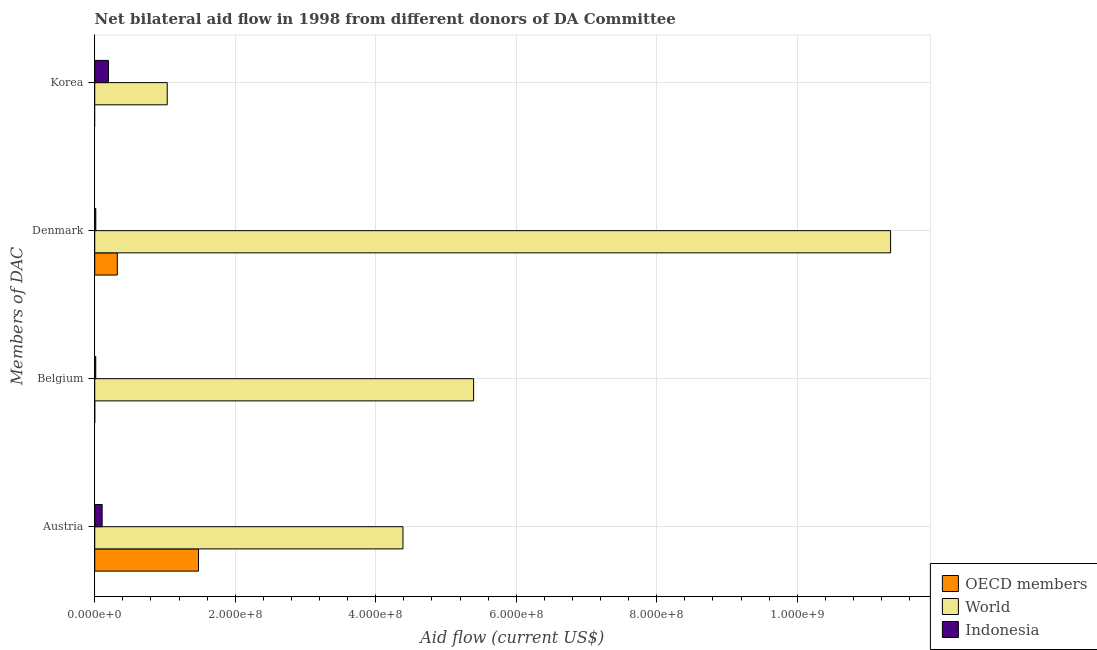How many groups of bars are there?
Give a very brief answer. 4. Are the number of bars per tick equal to the number of legend labels?
Your answer should be very brief. No. Are the number of bars on each tick of the Y-axis equal?
Offer a very short reply. No. How many bars are there on the 1st tick from the bottom?
Provide a succinct answer. 3. What is the label of the 1st group of bars from the top?
Provide a short and direct response. Korea. What is the amount of aid given by belgium in Indonesia?
Give a very brief answer. 1.45e+06. Across all countries, what is the maximum amount of aid given by belgium?
Provide a succinct answer. 5.39e+08. Across all countries, what is the minimum amount of aid given by denmark?
Keep it short and to the point. 1.51e+06. What is the total amount of aid given by belgium in the graph?
Offer a very short reply. 5.41e+08. What is the difference between the amount of aid given by austria in Indonesia and that in OECD members?
Ensure brevity in your answer.  -1.37e+08. What is the difference between the amount of aid given by belgium in World and the amount of aid given by denmark in Indonesia?
Provide a succinct answer. 5.38e+08. What is the average amount of aid given by belgium per country?
Keep it short and to the point. 1.80e+08. What is the difference between the amount of aid given by austria and amount of aid given by belgium in World?
Ensure brevity in your answer.  -1.01e+08. In how many countries, is the amount of aid given by austria greater than 920000000 US$?
Your response must be concise. 0. What is the ratio of the amount of aid given by denmark in OECD members to that in World?
Ensure brevity in your answer.  0.03. Is the amount of aid given by austria in OECD members less than that in World?
Provide a succinct answer. Yes. Is the difference between the amount of aid given by korea in World and Indonesia greater than the difference between the amount of aid given by austria in World and Indonesia?
Ensure brevity in your answer.  No. What is the difference between the highest and the second highest amount of aid given by austria?
Keep it short and to the point. 2.91e+08. What is the difference between the highest and the lowest amount of aid given by denmark?
Provide a succinct answer. 1.13e+09. Is the sum of the amount of aid given by belgium in World and Indonesia greater than the maximum amount of aid given by denmark across all countries?
Make the answer very short. No. How many bars are there?
Offer a very short reply. 10. Are all the bars in the graph horizontal?
Your answer should be very brief. Yes. How many countries are there in the graph?
Your answer should be very brief. 3. What is the difference between two consecutive major ticks on the X-axis?
Make the answer very short. 2.00e+08. Does the graph contain any zero values?
Offer a terse response. Yes. Does the graph contain grids?
Your answer should be compact. Yes. Where does the legend appear in the graph?
Ensure brevity in your answer.  Bottom right. How many legend labels are there?
Provide a short and direct response. 3. What is the title of the graph?
Keep it short and to the point. Net bilateral aid flow in 1998 from different donors of DA Committee. What is the label or title of the X-axis?
Offer a very short reply. Aid flow (current US$). What is the label or title of the Y-axis?
Ensure brevity in your answer.  Members of DAC. What is the Aid flow (current US$) of OECD members in Austria?
Offer a terse response. 1.48e+08. What is the Aid flow (current US$) in World in Austria?
Your answer should be very brief. 4.39e+08. What is the Aid flow (current US$) of Indonesia in Austria?
Offer a very short reply. 1.05e+07. What is the Aid flow (current US$) in OECD members in Belgium?
Your answer should be compact. 0. What is the Aid flow (current US$) in World in Belgium?
Provide a short and direct response. 5.39e+08. What is the Aid flow (current US$) in Indonesia in Belgium?
Your answer should be compact. 1.45e+06. What is the Aid flow (current US$) in OECD members in Denmark?
Your answer should be compact. 3.22e+07. What is the Aid flow (current US$) of World in Denmark?
Give a very brief answer. 1.13e+09. What is the Aid flow (current US$) in Indonesia in Denmark?
Your answer should be very brief. 1.51e+06. What is the Aid flow (current US$) in OECD members in Korea?
Your answer should be compact. 0. What is the Aid flow (current US$) of World in Korea?
Your answer should be very brief. 1.03e+08. What is the Aid flow (current US$) in Indonesia in Korea?
Provide a short and direct response. 1.96e+07. Across all Members of DAC, what is the maximum Aid flow (current US$) in OECD members?
Keep it short and to the point. 1.48e+08. Across all Members of DAC, what is the maximum Aid flow (current US$) in World?
Ensure brevity in your answer.  1.13e+09. Across all Members of DAC, what is the maximum Aid flow (current US$) in Indonesia?
Your answer should be compact. 1.96e+07. Across all Members of DAC, what is the minimum Aid flow (current US$) in World?
Keep it short and to the point. 1.03e+08. Across all Members of DAC, what is the minimum Aid flow (current US$) in Indonesia?
Offer a terse response. 1.45e+06. What is the total Aid flow (current US$) in OECD members in the graph?
Provide a short and direct response. 1.80e+08. What is the total Aid flow (current US$) in World in the graph?
Your answer should be very brief. 2.21e+09. What is the total Aid flow (current US$) of Indonesia in the graph?
Make the answer very short. 3.30e+07. What is the difference between the Aid flow (current US$) in World in Austria and that in Belgium?
Give a very brief answer. -1.01e+08. What is the difference between the Aid flow (current US$) in Indonesia in Austria and that in Belgium?
Your answer should be very brief. 9.09e+06. What is the difference between the Aid flow (current US$) of OECD members in Austria and that in Denmark?
Make the answer very short. 1.16e+08. What is the difference between the Aid flow (current US$) in World in Austria and that in Denmark?
Keep it short and to the point. -6.94e+08. What is the difference between the Aid flow (current US$) in Indonesia in Austria and that in Denmark?
Offer a very short reply. 9.03e+06. What is the difference between the Aid flow (current US$) of World in Austria and that in Korea?
Make the answer very short. 3.36e+08. What is the difference between the Aid flow (current US$) in Indonesia in Austria and that in Korea?
Offer a very short reply. -9.01e+06. What is the difference between the Aid flow (current US$) of World in Belgium and that in Denmark?
Keep it short and to the point. -5.94e+08. What is the difference between the Aid flow (current US$) of World in Belgium and that in Korea?
Ensure brevity in your answer.  4.36e+08. What is the difference between the Aid flow (current US$) in Indonesia in Belgium and that in Korea?
Give a very brief answer. -1.81e+07. What is the difference between the Aid flow (current US$) in World in Denmark and that in Korea?
Offer a terse response. 1.03e+09. What is the difference between the Aid flow (current US$) in Indonesia in Denmark and that in Korea?
Offer a terse response. -1.80e+07. What is the difference between the Aid flow (current US$) of OECD members in Austria and the Aid flow (current US$) of World in Belgium?
Keep it short and to the point. -3.92e+08. What is the difference between the Aid flow (current US$) in OECD members in Austria and the Aid flow (current US$) in Indonesia in Belgium?
Provide a short and direct response. 1.46e+08. What is the difference between the Aid flow (current US$) in World in Austria and the Aid flow (current US$) in Indonesia in Belgium?
Your answer should be very brief. 4.37e+08. What is the difference between the Aid flow (current US$) of OECD members in Austria and the Aid flow (current US$) of World in Denmark?
Offer a very short reply. -9.85e+08. What is the difference between the Aid flow (current US$) of OECD members in Austria and the Aid flow (current US$) of Indonesia in Denmark?
Offer a very short reply. 1.46e+08. What is the difference between the Aid flow (current US$) in World in Austria and the Aid flow (current US$) in Indonesia in Denmark?
Your answer should be compact. 4.37e+08. What is the difference between the Aid flow (current US$) of OECD members in Austria and the Aid flow (current US$) of World in Korea?
Offer a terse response. 4.45e+07. What is the difference between the Aid flow (current US$) of OECD members in Austria and the Aid flow (current US$) of Indonesia in Korea?
Give a very brief answer. 1.28e+08. What is the difference between the Aid flow (current US$) of World in Austria and the Aid flow (current US$) of Indonesia in Korea?
Provide a short and direct response. 4.19e+08. What is the difference between the Aid flow (current US$) of World in Belgium and the Aid flow (current US$) of Indonesia in Denmark?
Provide a short and direct response. 5.38e+08. What is the difference between the Aid flow (current US$) of World in Belgium and the Aid flow (current US$) of Indonesia in Korea?
Keep it short and to the point. 5.20e+08. What is the difference between the Aid flow (current US$) in OECD members in Denmark and the Aid flow (current US$) in World in Korea?
Offer a very short reply. -7.11e+07. What is the difference between the Aid flow (current US$) in OECD members in Denmark and the Aid flow (current US$) in Indonesia in Korea?
Your response must be concise. 1.26e+07. What is the difference between the Aid flow (current US$) of World in Denmark and the Aid flow (current US$) of Indonesia in Korea?
Provide a succinct answer. 1.11e+09. What is the average Aid flow (current US$) in OECD members per Members of DAC?
Your answer should be compact. 4.50e+07. What is the average Aid flow (current US$) of World per Members of DAC?
Offer a very short reply. 5.54e+08. What is the average Aid flow (current US$) in Indonesia per Members of DAC?
Ensure brevity in your answer.  8.26e+06. What is the difference between the Aid flow (current US$) in OECD members and Aid flow (current US$) in World in Austria?
Keep it short and to the point. -2.91e+08. What is the difference between the Aid flow (current US$) of OECD members and Aid flow (current US$) of Indonesia in Austria?
Provide a succinct answer. 1.37e+08. What is the difference between the Aid flow (current US$) of World and Aid flow (current US$) of Indonesia in Austria?
Offer a very short reply. 4.28e+08. What is the difference between the Aid flow (current US$) of World and Aid flow (current US$) of Indonesia in Belgium?
Your response must be concise. 5.38e+08. What is the difference between the Aid flow (current US$) in OECD members and Aid flow (current US$) in World in Denmark?
Your response must be concise. -1.10e+09. What is the difference between the Aid flow (current US$) in OECD members and Aid flow (current US$) in Indonesia in Denmark?
Provide a short and direct response. 3.06e+07. What is the difference between the Aid flow (current US$) of World and Aid flow (current US$) of Indonesia in Denmark?
Keep it short and to the point. 1.13e+09. What is the difference between the Aid flow (current US$) in World and Aid flow (current US$) in Indonesia in Korea?
Provide a succinct answer. 8.37e+07. What is the ratio of the Aid flow (current US$) in World in Austria to that in Belgium?
Keep it short and to the point. 0.81. What is the ratio of the Aid flow (current US$) of Indonesia in Austria to that in Belgium?
Provide a succinct answer. 7.27. What is the ratio of the Aid flow (current US$) in OECD members in Austria to that in Denmark?
Your answer should be compact. 4.59. What is the ratio of the Aid flow (current US$) of World in Austria to that in Denmark?
Provide a succinct answer. 0.39. What is the ratio of the Aid flow (current US$) of Indonesia in Austria to that in Denmark?
Offer a very short reply. 6.98. What is the ratio of the Aid flow (current US$) of World in Austria to that in Korea?
Provide a short and direct response. 4.25. What is the ratio of the Aid flow (current US$) in Indonesia in Austria to that in Korea?
Ensure brevity in your answer.  0.54. What is the ratio of the Aid flow (current US$) of World in Belgium to that in Denmark?
Make the answer very short. 0.48. What is the ratio of the Aid flow (current US$) of Indonesia in Belgium to that in Denmark?
Your response must be concise. 0.96. What is the ratio of the Aid flow (current US$) of World in Belgium to that in Korea?
Your answer should be very brief. 5.23. What is the ratio of the Aid flow (current US$) of Indonesia in Belgium to that in Korea?
Your response must be concise. 0.07. What is the ratio of the Aid flow (current US$) in World in Denmark to that in Korea?
Your answer should be very brief. 10.98. What is the ratio of the Aid flow (current US$) of Indonesia in Denmark to that in Korea?
Your answer should be compact. 0.08. What is the difference between the highest and the second highest Aid flow (current US$) of World?
Give a very brief answer. 5.94e+08. What is the difference between the highest and the second highest Aid flow (current US$) in Indonesia?
Provide a succinct answer. 9.01e+06. What is the difference between the highest and the lowest Aid flow (current US$) of OECD members?
Your answer should be compact. 1.48e+08. What is the difference between the highest and the lowest Aid flow (current US$) in World?
Provide a succinct answer. 1.03e+09. What is the difference between the highest and the lowest Aid flow (current US$) in Indonesia?
Your answer should be very brief. 1.81e+07. 